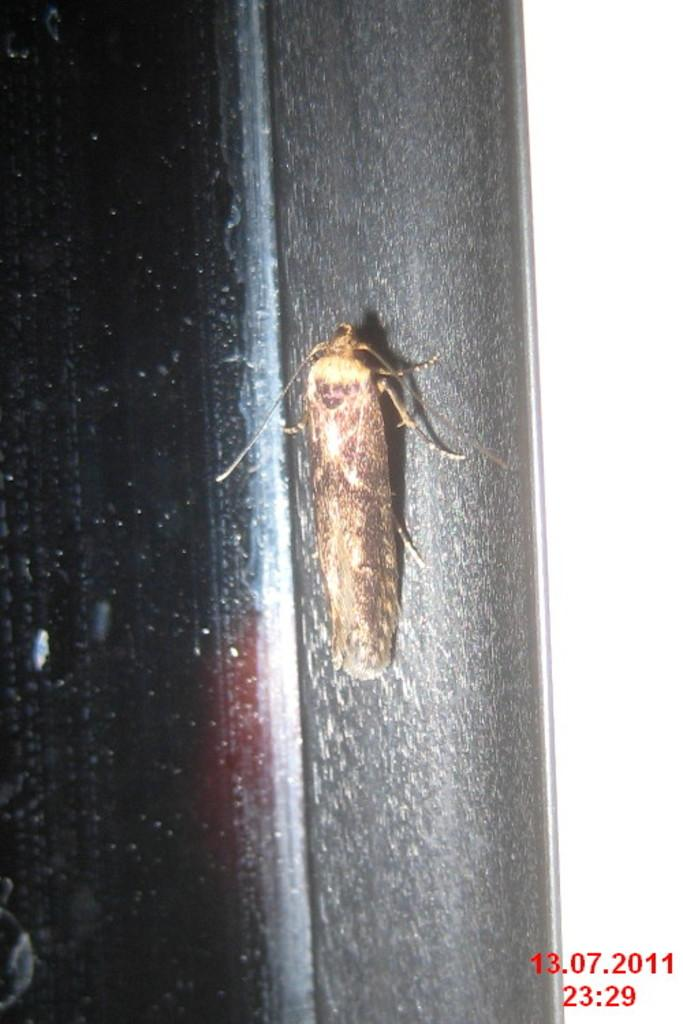What is the main subject of the image? The main subject of the image is a cockroach on a black pole. What type of structure can be seen in the image? There is a glass window in the image. How would you describe the lighting in the image? The left side of the image is dark, while the right side is white in color. What rate of growth is suggested for the cockroach in the image? There is no information about the growth rate of the cockroach in the image, as it is a static image and not a video or time-lapse. 